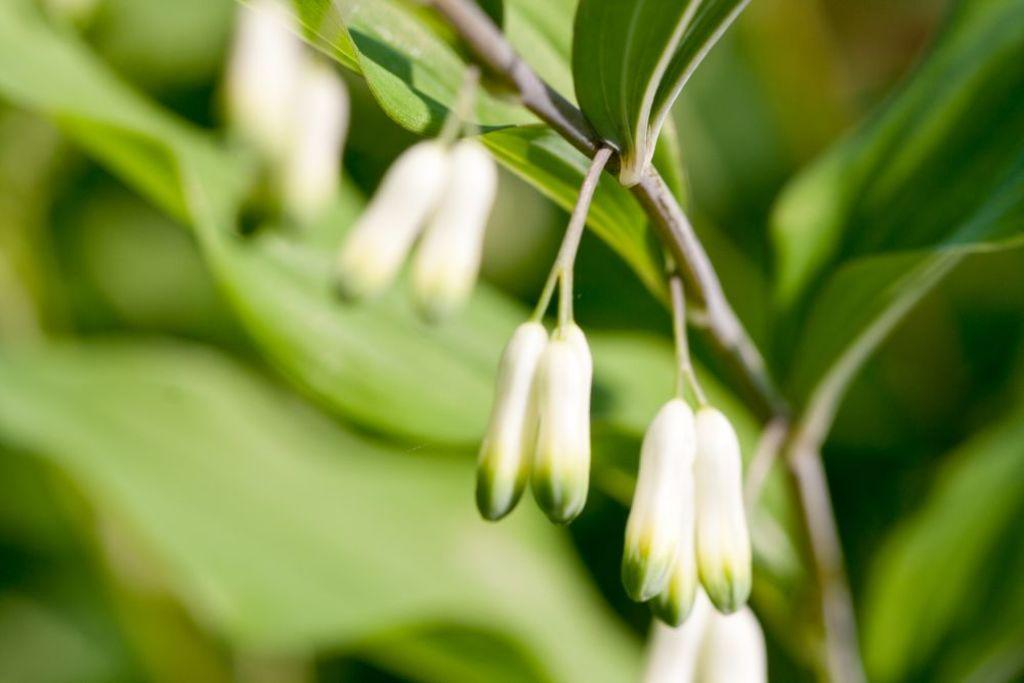What type of plant life is present in the image? There are flower buds in the image. What colors are the flower buds? The flower buds are in white and green color. Can you describe the background of the image? The background of the image is blurred. What type of goldfish can be seen swimming in the image? There are no goldfish present in the image; it features flower buds in white and green color with a blurred background. What is your opinion on the ray's migration patterns in the image? There is no mention of a ray or its migration patterns in the image; it only contains flower buds in white and green color with a blurred background. 